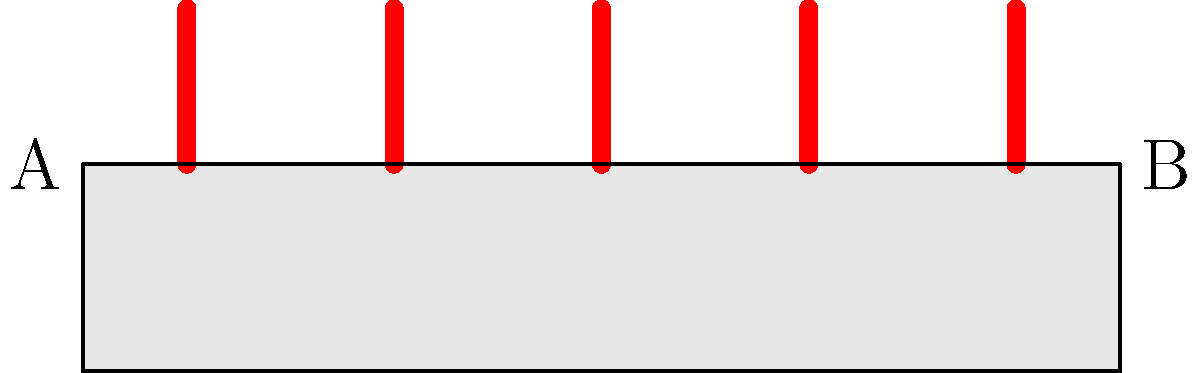Consider the arrangement of candles on the altar shown in the diagram. The altar has a rectangular shape with endpoints A and B. If we apply a reflection symmetry operation about the vertical line passing through the center of the altar, how many candles will remain in their original positions? To solve this problem, let's follow these steps:

1. Identify the line of symmetry:
   The vertical line passing through the center of the altar is halfway between points A and B.

2. Count the total number of candles:
   There are 5 candles placed on the altar.

3. Determine the positions of candles relative to the line of symmetry:
   - The middle candle is placed exactly on the line of symmetry.
   - Two candles are to the left of the line of symmetry.
   - Two candles are to the right of the line of symmetry.

4. Apply the reflection symmetry operation:
   - The middle candle, being on the line of symmetry, will remain in its original position.
   - The two candles on the left will be reflected to the positions of the two candles on the right, and vice versa.

5. Count the number of candles that remain in their original positions:
   Only the middle candle remains in its original position after the reflection.

Therefore, 1 candle will remain in its original position after applying the reflection symmetry operation.
Answer: 1 candle 